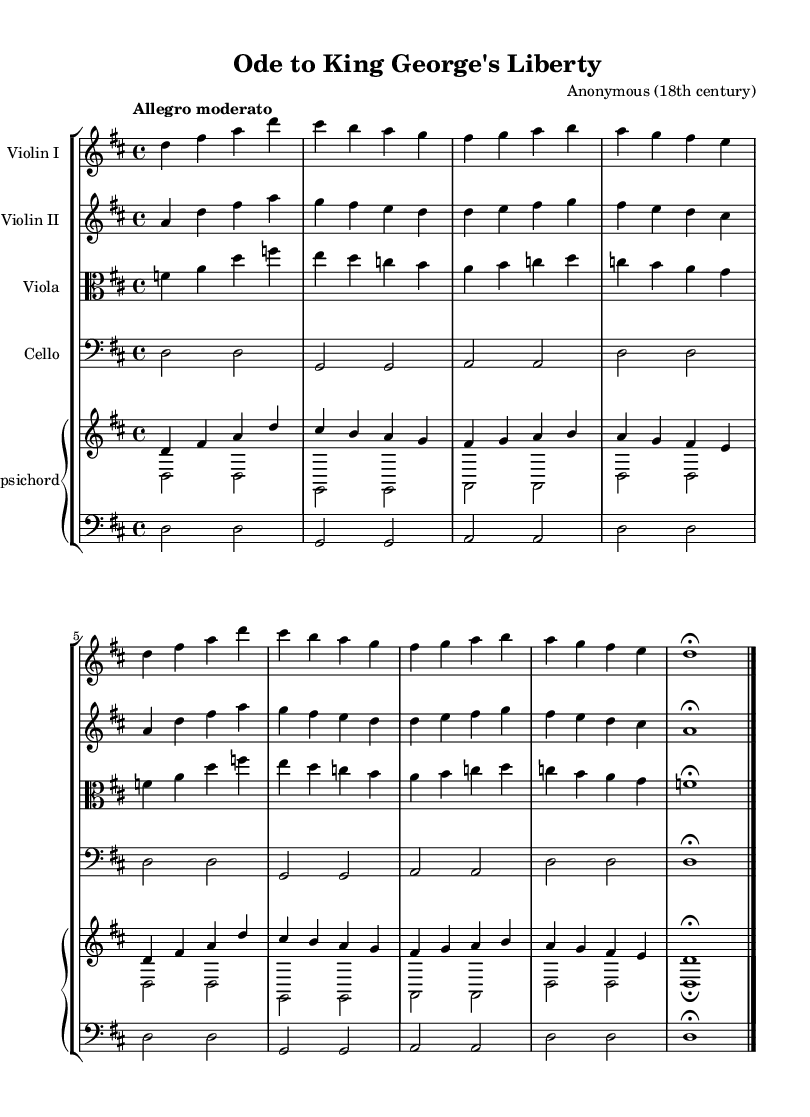What is the title of the piece? The title is clearly indicated in the header section of the sheet music. It reads "Ode to King George's Liberty".
Answer: Ode to King George's Liberty What is the key signature of this music? The key signature is marked at the beginning of the score. It shows two sharps, which indicates the key of D major.
Answer: D major What is the time signature? The time signature is shown at the beginning of the score and is indicated by the fraction 4/4, meaning there are four beats per measure.
Answer: 4/4 What is the tempo marking? The tempo marking is indicated near the beginning of the music and it describes the recommended speed. It reads "Allegro moderato".
Answer: Allegro moderato What instruments are featured in this piece? The instruments are notated at the beginning of each staff in the score. They include Violin I, Violin II, Viola, Cello, and Harpsichord.
Answer: Violin I, Violin II, Viola, Cello, Harpsichord What type of composition is this? Observing the instrumentation and the nature of the composition, this piece can be classified as a string ensemble piece, likely intended for performance.
Answer: String ensemble Why might this piece be considered patriotic? Considering the title "Ode to King George's Liberty," it suggests themes of freedom and national identity, which were significant during the American Revolutionary War. It reflects sentiments of loyalty and celebration.
Answer: Themes of freedom and national identity 